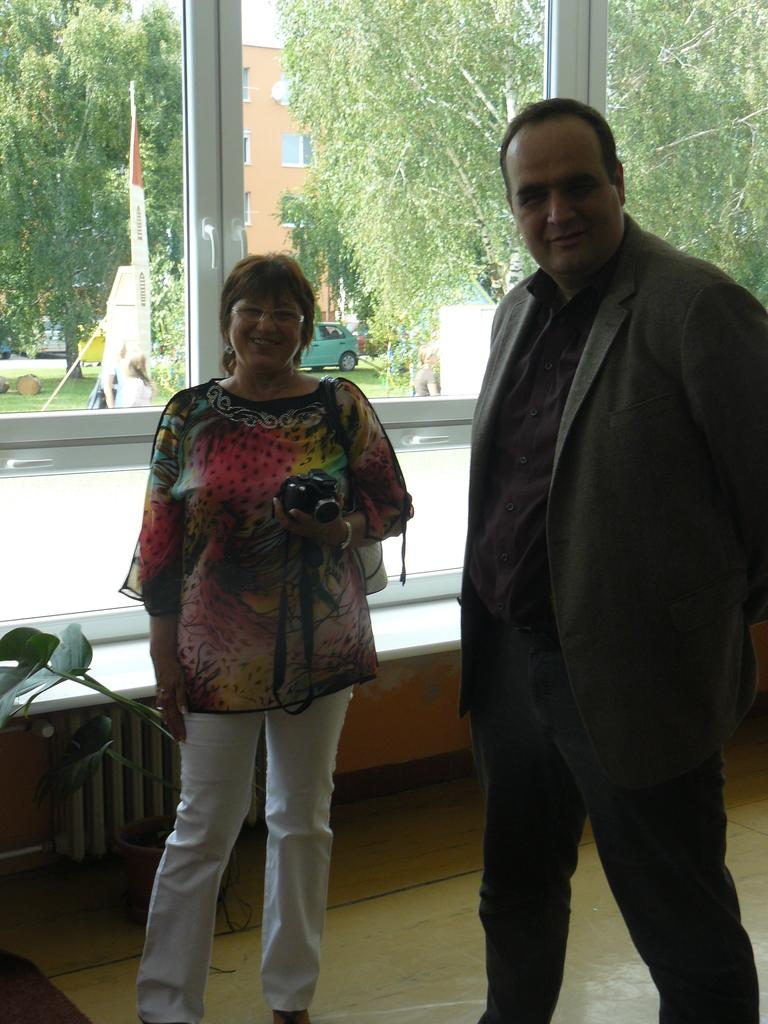What is the main subject of the image? There is a person standing in the image. Can you describe the person holding a camera in the image? There is a woman holding a camera in the image. What type of architectural feature can be seen in the background of the image? There are glass windows on the wall in the background of the image. What type of book is the person reading in the image? There is no book or reading activity present in the image. Can you tell me what type of hospital the person is standing in front of in the image? There is no hospital or any indication of a hospital setting in the image. 